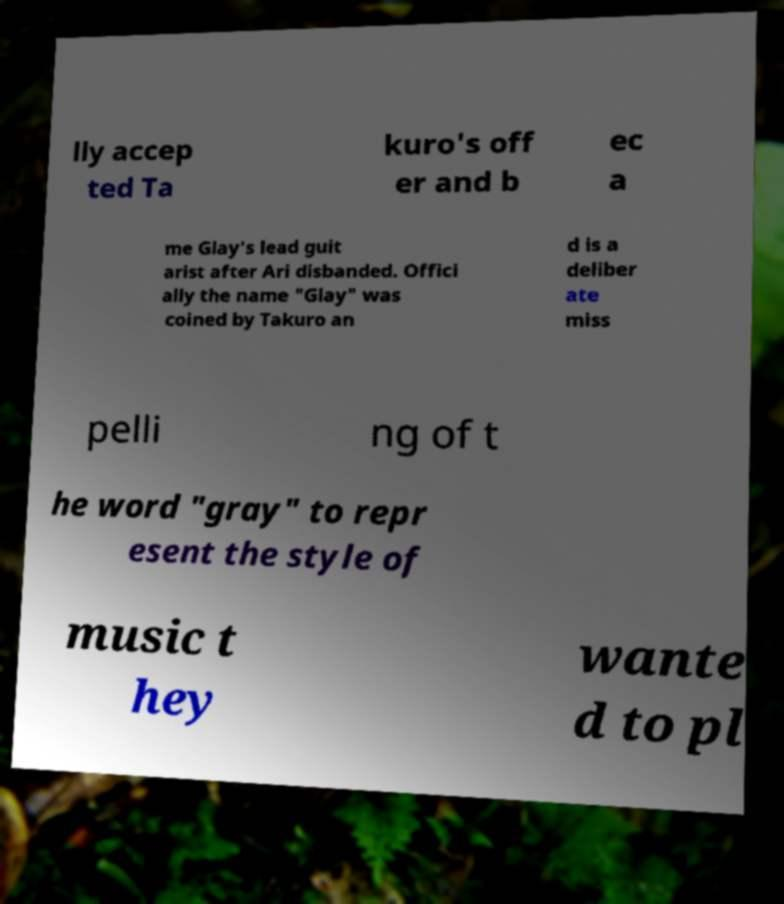Could you assist in decoding the text presented in this image and type it out clearly? lly accep ted Ta kuro's off er and b ec a me Glay's lead guit arist after Ari disbanded. Offici ally the name "Glay" was coined by Takuro an d is a deliber ate miss pelli ng of t he word "gray" to repr esent the style of music t hey wante d to pl 